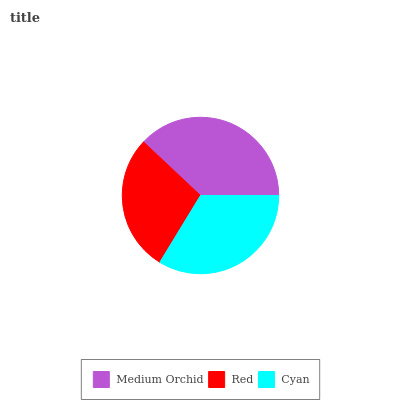Is Red the minimum?
Answer yes or no. Yes. Is Medium Orchid the maximum?
Answer yes or no. Yes. Is Cyan the minimum?
Answer yes or no. No. Is Cyan the maximum?
Answer yes or no. No. Is Cyan greater than Red?
Answer yes or no. Yes. Is Red less than Cyan?
Answer yes or no. Yes. Is Red greater than Cyan?
Answer yes or no. No. Is Cyan less than Red?
Answer yes or no. No. Is Cyan the high median?
Answer yes or no. Yes. Is Cyan the low median?
Answer yes or no. Yes. Is Medium Orchid the high median?
Answer yes or no. No. Is Red the low median?
Answer yes or no. No. 